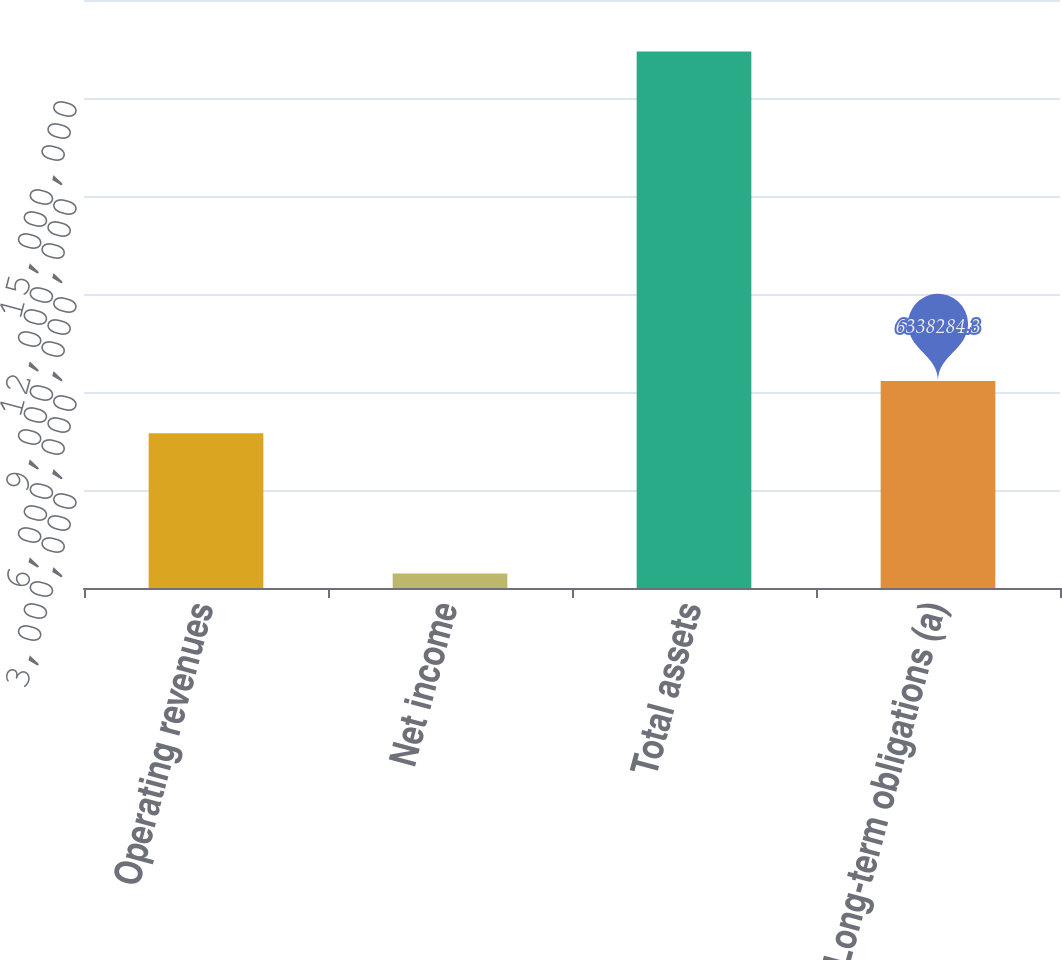Convert chart to OTSL. <chart><loc_0><loc_0><loc_500><loc_500><bar_chart><fcel>Operating revenues<fcel>Net income<fcel>Total assets<fcel>Long-term obligations (a)<nl><fcel>4.7405e+06<fcel>446022<fcel>1.64238e+07<fcel>6.33828e+06<nl></chart> 